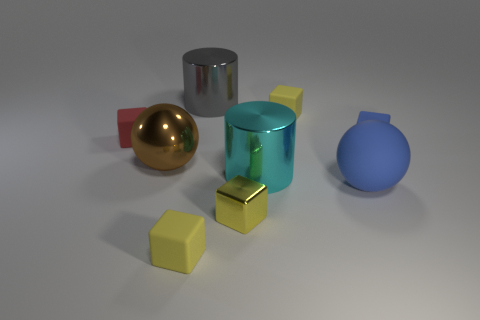Subtract all green cylinders. How many yellow blocks are left? 3 Subtract 2 cubes. How many cubes are left? 3 Subtract all gray cubes. Subtract all purple cylinders. How many cubes are left? 5 Subtract all cylinders. How many objects are left? 7 Subtract 0 purple cubes. How many objects are left? 9 Subtract all brown metallic objects. Subtract all tiny red shiny cylinders. How many objects are left? 8 Add 2 cubes. How many cubes are left? 7 Add 6 large rubber balls. How many large rubber balls exist? 7 